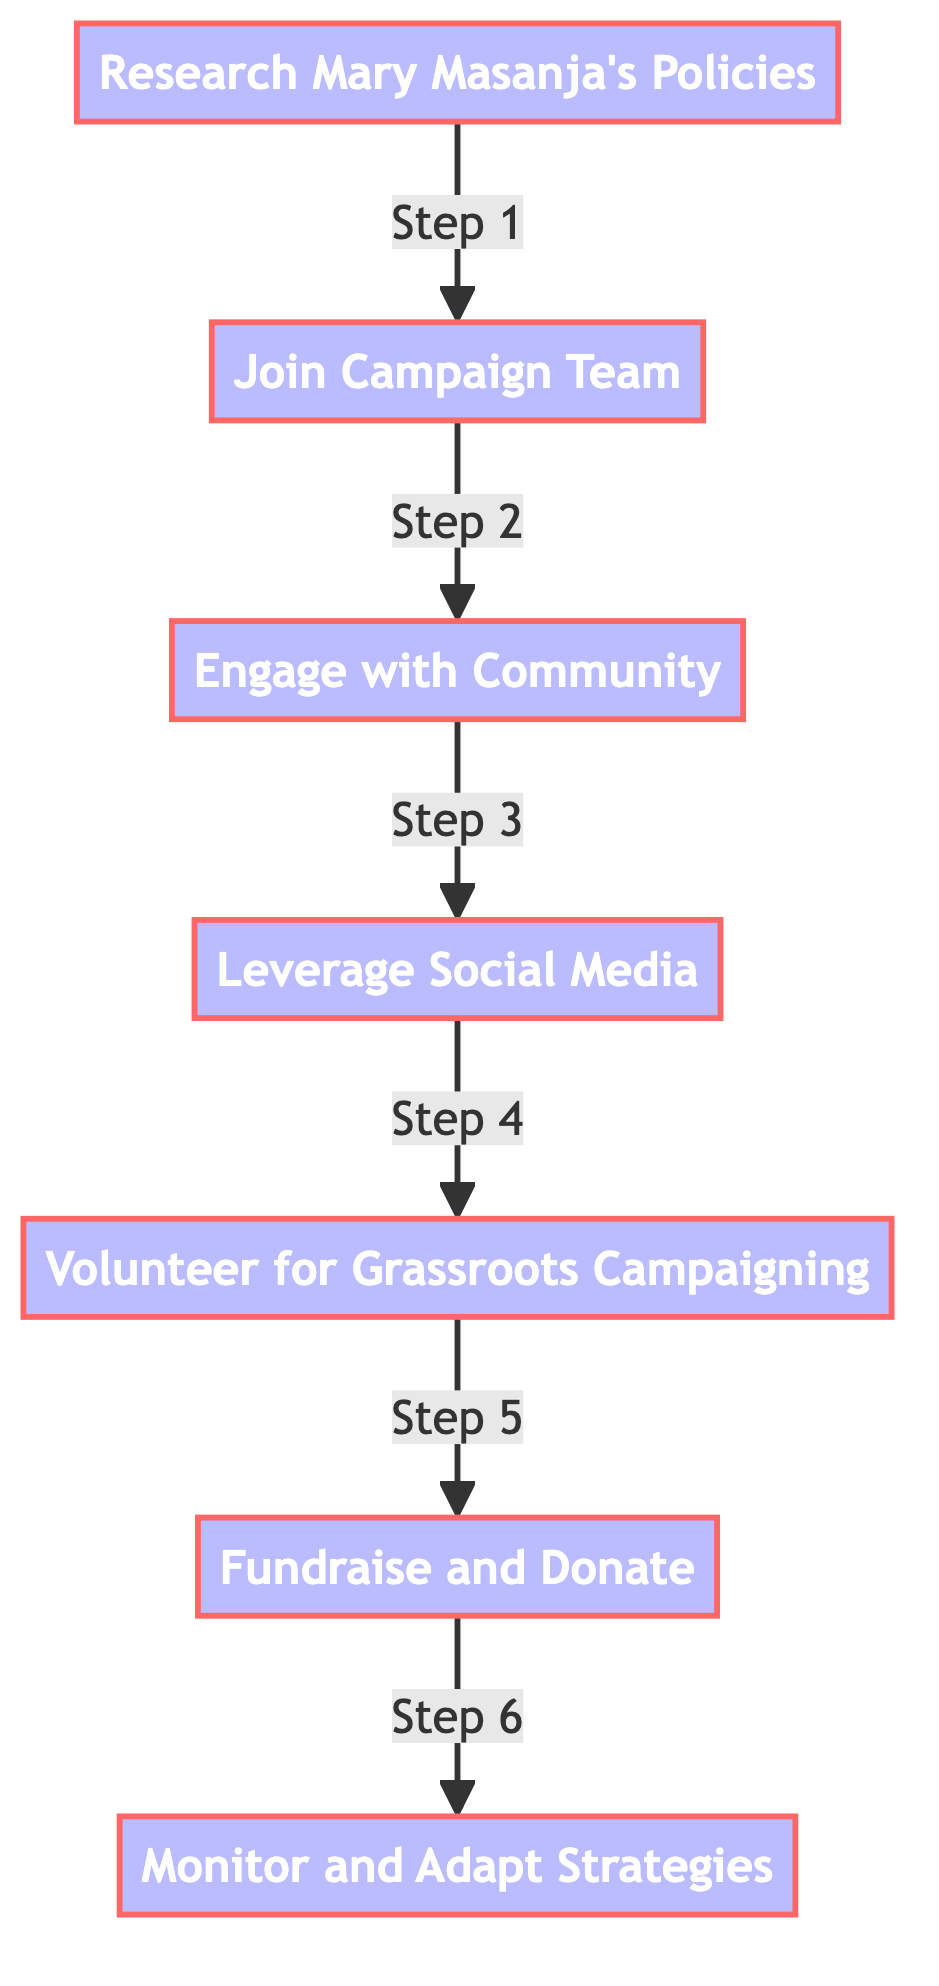What is the first step in campaigning for Mary Masanja? The first step, as indicated in the diagram, is "Research and Understand Mary Masanja's Policies." This is the starting point and sets the foundation for further actions in the campaign.
Answer: Research and Understand Mary Masanja's Policies How many total steps are outlined for the campaign? By reviewing the flowchart, we can count a total of seven steps listed that are necessary to effectively campaign for Mary Masanja.
Answer: 7 What step comes after engaging with the community? From the flowchart, after "Engage with the Community," the next step is "Leverage Social Media Platforms." This gives a clear direction of action following community engagement.
Answer: Leverage Social Media Platforms Which step focuses on fundraising? The step related to fundraising, as depicted in the diagram, is "Fundraise and Donate." This step clearly mentions the activities associated with raising funds for the campaign.
Answer: Fundraise and Donate What are the last two steps in the campaign process? The last two steps in the process are "Fundraise and Donate" followed by "Monitor and Adapt Strategies." This shows the progression towards maintaining and improving the campaign efforts at the end.
Answer: Fundraise and Donate, Monitor and Adapt Strategies How is social media utilized in the campaigning process? The flowchart specifies that social media is utilized in the step titled "Leverage Social Media Platforms," which involves creating and sharing content to engage with supporters and potential voters.
Answer: Leverage Social Media Platforms What is the overarching goal of joining Mary Masanja's campaign team? Joining the campaign team aims to mobilize support and gain understanding of the campaign structure and key contacts, which is crucial for effective campaigning.
Answer: Mobilize support and gain understanding 